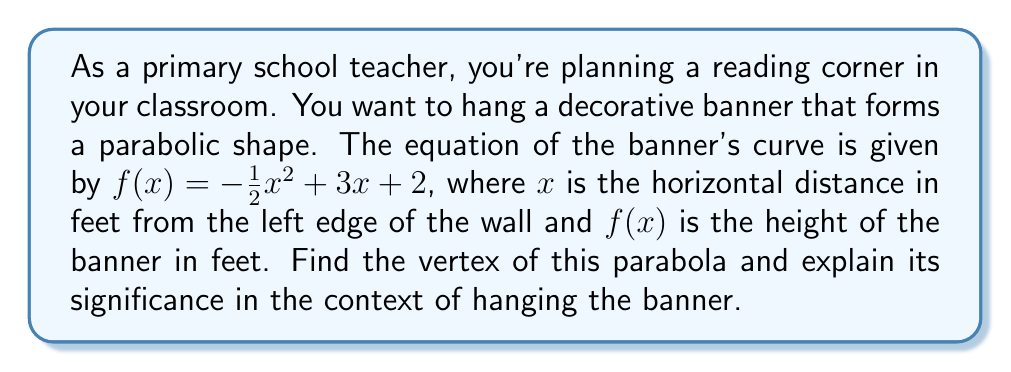Could you help me with this problem? To find the vertex of the parabola, we'll follow these steps:

1) The general form of a quadratic equation is $f(x) = ax^2 + bx + c$. In this case:
   $a = -\frac{1}{2}$, $b = 3$, and $c = 2$

2) For a parabola in the form $f(x) = ax^2 + bx + c$, the x-coordinate of the vertex is given by the formula $x = -\frac{b}{2a}$:

   $x = -\frac{3}{2(-\frac{1}{2})} = -\frac{3}{-1} = 3$

3) To find the y-coordinate, we substitute x = 3 into the original equation:

   $f(3) = -\frac{1}{2}(3)^2 + 3(3) + 2$
   $= -\frac{1}{2}(9) + 9 + 2$
   $= -4.5 + 9 + 2$
   $= 6.5$

4) Therefore, the vertex is (3, 6.5)

The significance of this vertex in the context of hanging the banner:
- The x-coordinate (3) represents the horizontal distance from the left edge of the wall where the banner will reach its highest point.
- The y-coordinate (6.5) represents the maximum height of the banner.
- This point is crucial for determining where to place support hooks or attachments for the banner, ensuring it hangs properly and achieves the desired parabolic shape.
- It also helps in planning the overall layout of the reading corner, ensuring the banner doesn't interfere with other decorations or functional elements of the space.
Answer: Vertex: (3, 6.5) feet. Significance: Highest point of banner, 3 feet from left wall and 6.5 feet high. 